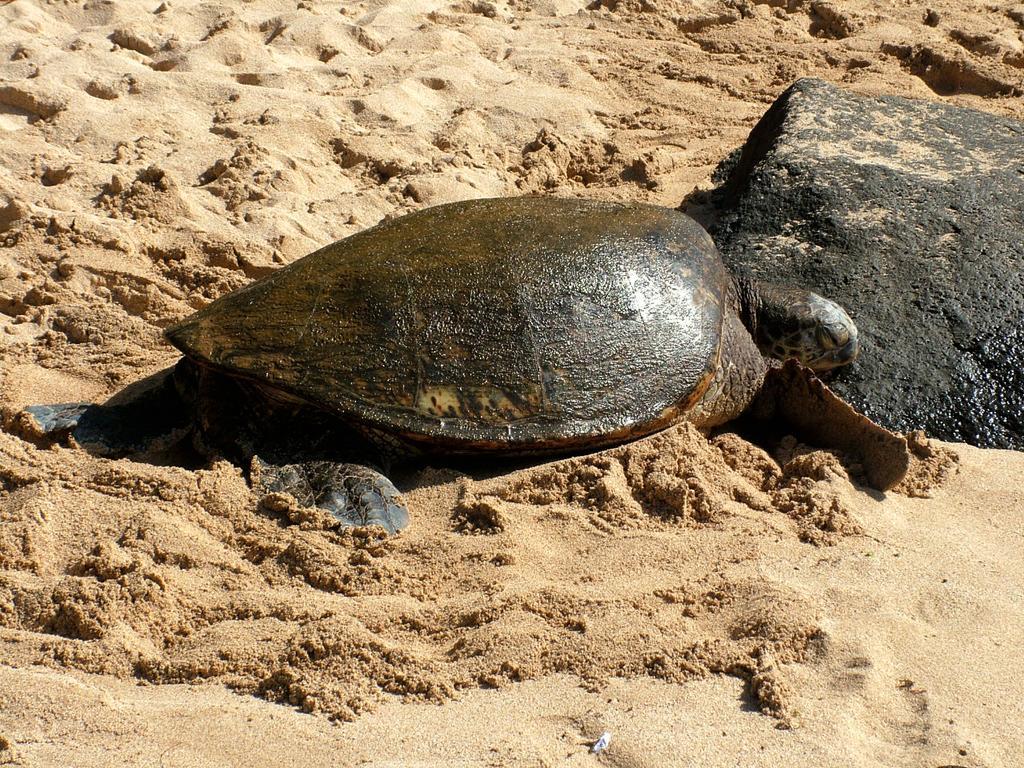Please provide a concise description of this image. In this picture we can see a turtle, at the bottom there is sand, we can see a rock on the right side. 